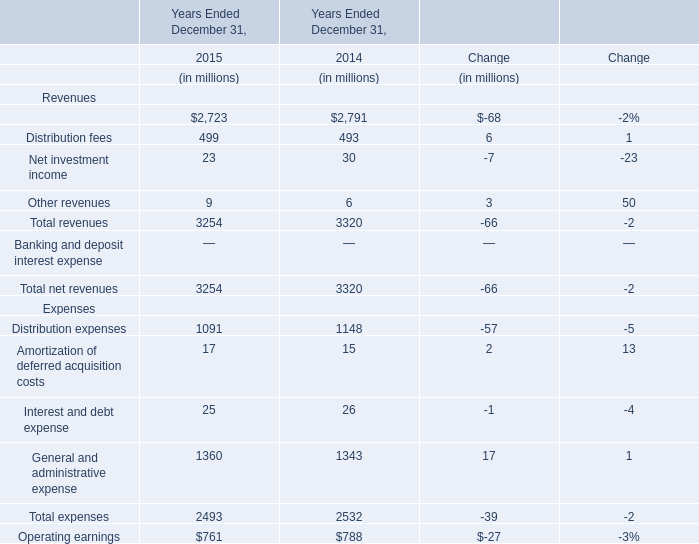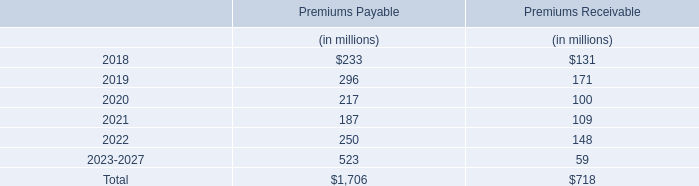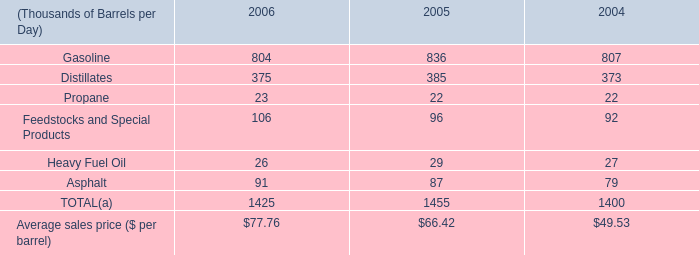What's the total amount of the Distribution fees in the years where Management and financial advice fees is greater than 2750? (in million) 
Answer: 493. 